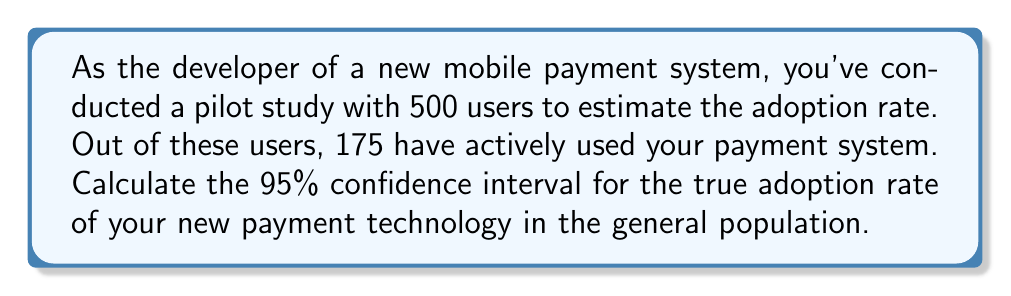Can you answer this question? Let's approach this step-by-step:

1) First, we need to calculate the sample proportion (p̂):
   $$\hat{p} = \frac{\text{Number of successes}}{\text{Total sample size}} = \frac{175}{500} = 0.35$$

2) The standard error (SE) for a proportion is given by:
   $$SE = \sqrt{\frac{\hat{p}(1-\hat{p})}{n}}$$
   Where n is the sample size.

3) Plugging in our values:
   $$SE = \sqrt{\frac{0.35(1-0.35)}{500}} = \sqrt{\frac{0.2275}{500}} = 0.0213$$

4) For a 95% confidence interval, we use a z-score of 1.96 (from the standard normal distribution).

5) The formula for the confidence interval is:
   $$\hat{p} \pm (z \times SE)$$

6) Substituting our values:
   $$0.35 \pm (1.96 \times 0.0213)$$
   $$0.35 \pm 0.0418$$

7) Therefore, the confidence interval is:
   $$(0.35 - 0.0418, 0.35 + 0.0418)$$
   $$(0.3082, 0.3918)$$
Answer: (0.3082, 0.3918) 